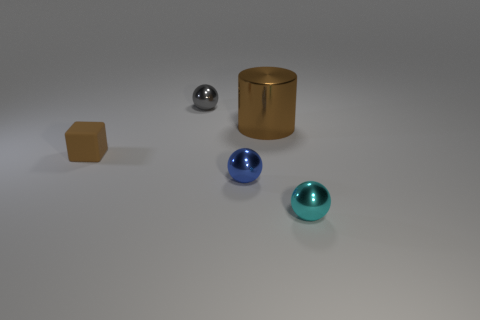How many small cyan shiny objects have the same shape as the small blue object?
Offer a terse response. 1. Does the gray shiny ball have the same size as the brown thing to the right of the gray thing?
Make the answer very short. No. What shape is the brown object that is to the left of the shiny ball that is behind the small brown rubber object?
Your answer should be very brief. Cube. Is the number of small balls that are left of the blue shiny object less than the number of metallic spheres?
Make the answer very short. Yes. There is a shiny thing that is the same color as the block; what is its shape?
Make the answer very short. Cylinder. How many gray metallic things have the same size as the gray shiny ball?
Your answer should be very brief. 0. What shape is the small object that is behind the large cylinder?
Your response must be concise. Sphere. Is the number of small cubes less than the number of cyan shiny cubes?
Your response must be concise. No. Is there anything else that has the same color as the tiny rubber thing?
Provide a succinct answer. Yes. There is a metal thing that is in front of the blue shiny ball; what is its size?
Ensure brevity in your answer.  Small. 